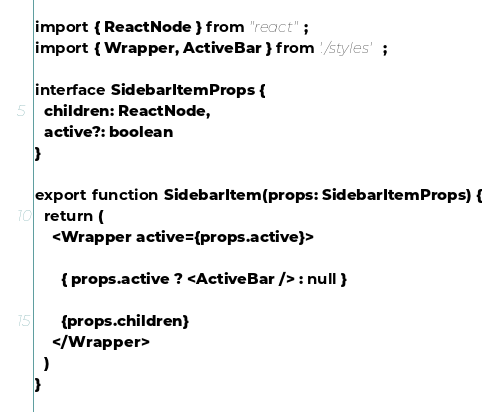<code> <loc_0><loc_0><loc_500><loc_500><_TypeScript_>import { ReactNode } from "react";
import { Wrapper, ActiveBar } from './styles';

interface SidebarItemProps {
  children: ReactNode,
  active?: boolean
}

export function SidebarItem(props: SidebarItemProps) {
  return (
    <Wrapper active={props.active}>
      
      { props.active ? <ActiveBar /> : null }
      
      {props.children}
    </Wrapper>
  )
}
</code> 